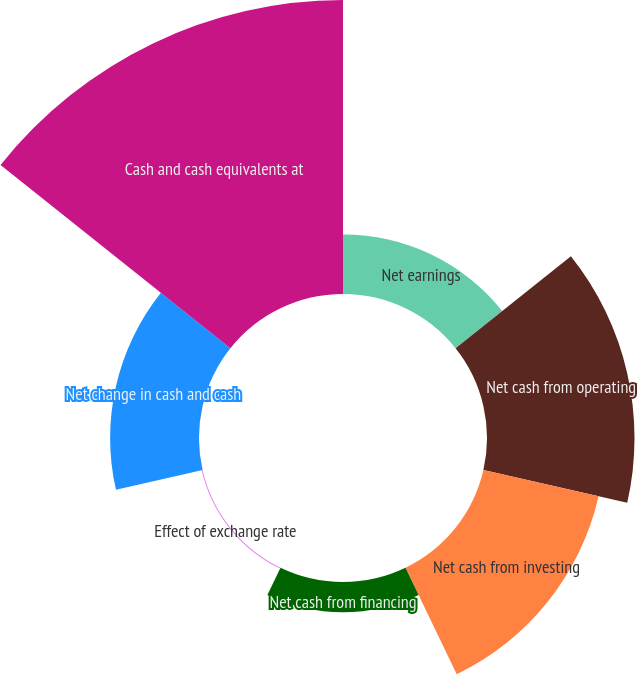Convert chart to OTSL. <chart><loc_0><loc_0><loc_500><loc_500><pie_chart><fcel>Net earnings<fcel>Net cash from operating<fcel>Net cash from investing<fcel>Net cash from financing<fcel>Effect of exchange rate<fcel>Net change in cash and cash<fcel>Cash and cash equivalents at<nl><fcel>8.06%<fcel>19.95%<fcel>15.98%<fcel>4.1%<fcel>0.13%<fcel>12.02%<fcel>39.76%<nl></chart> 